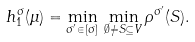Convert formula to latex. <formula><loc_0><loc_0><loc_500><loc_500>h ^ { \sigma } _ { 1 } ( \mu ) = \min _ { \sigma ^ { \prime } \in [ \sigma ] } \, \min _ { \emptyset \neq S \subseteq V } \rho ^ { \sigma ^ { \prime } } ( S ) .</formula> 